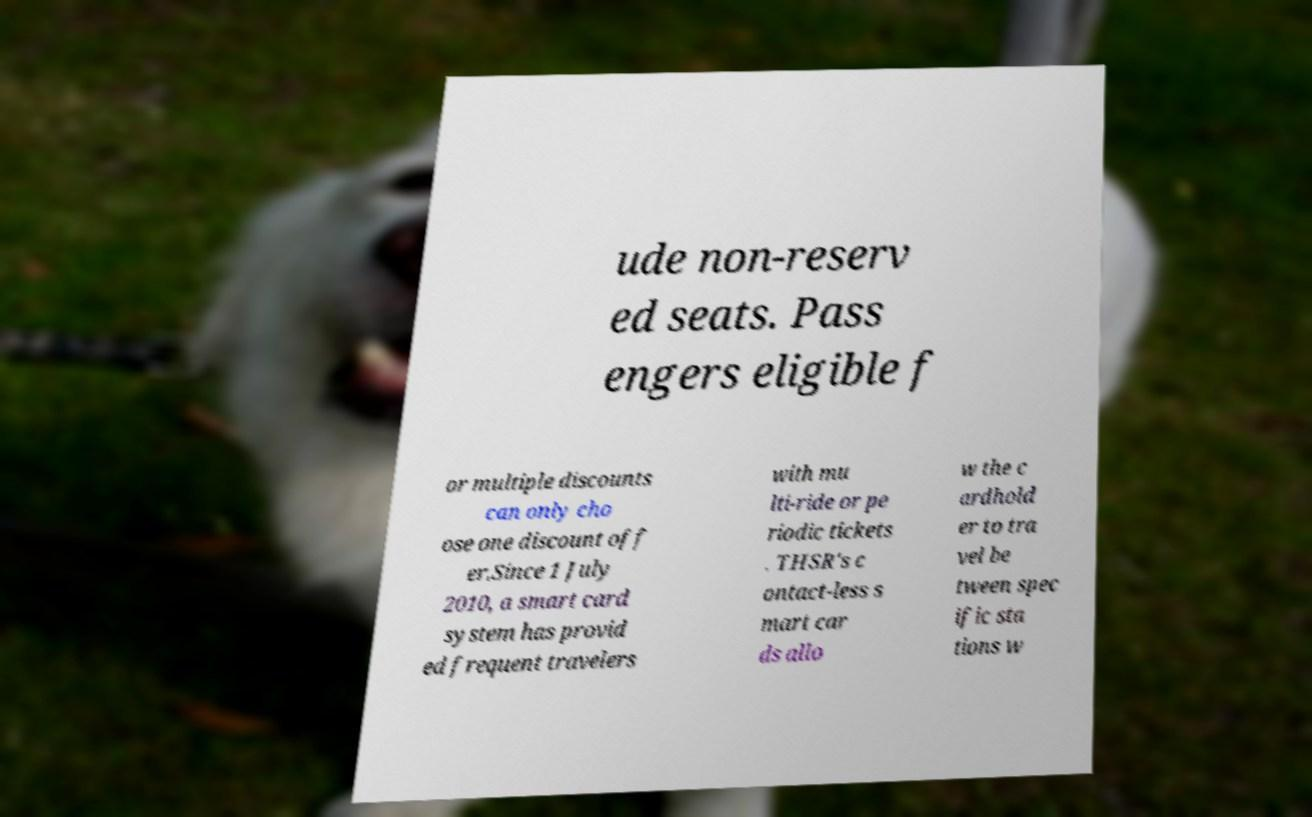I need the written content from this picture converted into text. Can you do that? ude non-reserv ed seats. Pass engers eligible f or multiple discounts can only cho ose one discount off er.Since 1 July 2010, a smart card system has provid ed frequent travelers with mu lti-ride or pe riodic tickets . THSR's c ontact-less s mart car ds allo w the c ardhold er to tra vel be tween spec ific sta tions w 